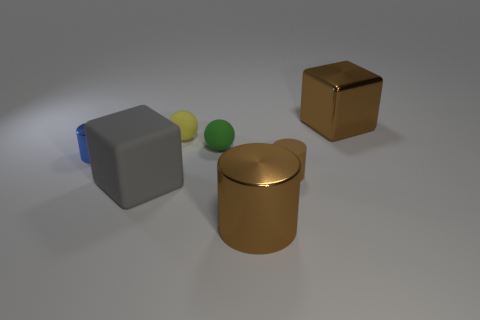Add 1 brown metal blocks. How many objects exist? 8 Subtract all blocks. How many objects are left? 5 Subtract 0 blue cubes. How many objects are left? 7 Subtract all big green matte objects. Subtract all spheres. How many objects are left? 5 Add 1 tiny blue metal cylinders. How many tiny blue metal cylinders are left? 2 Add 3 tiny things. How many tiny things exist? 7 